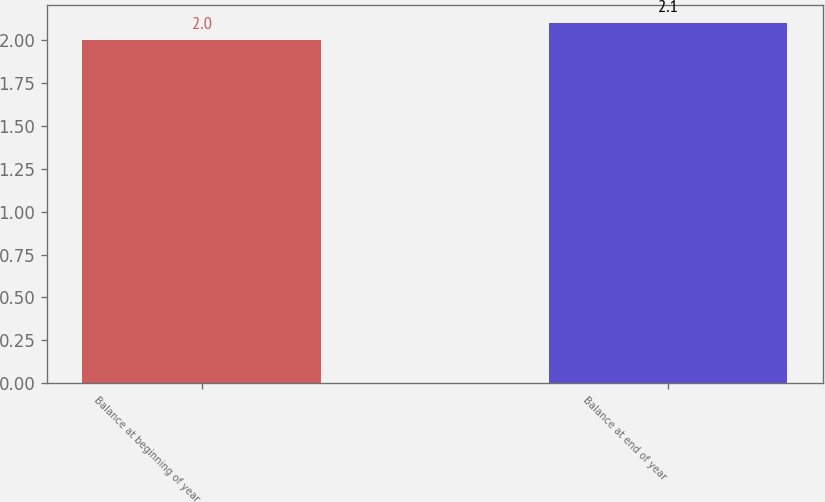<chart> <loc_0><loc_0><loc_500><loc_500><bar_chart><fcel>Balance at beginning of year<fcel>Balance at end of year<nl><fcel>2<fcel>2.1<nl></chart> 